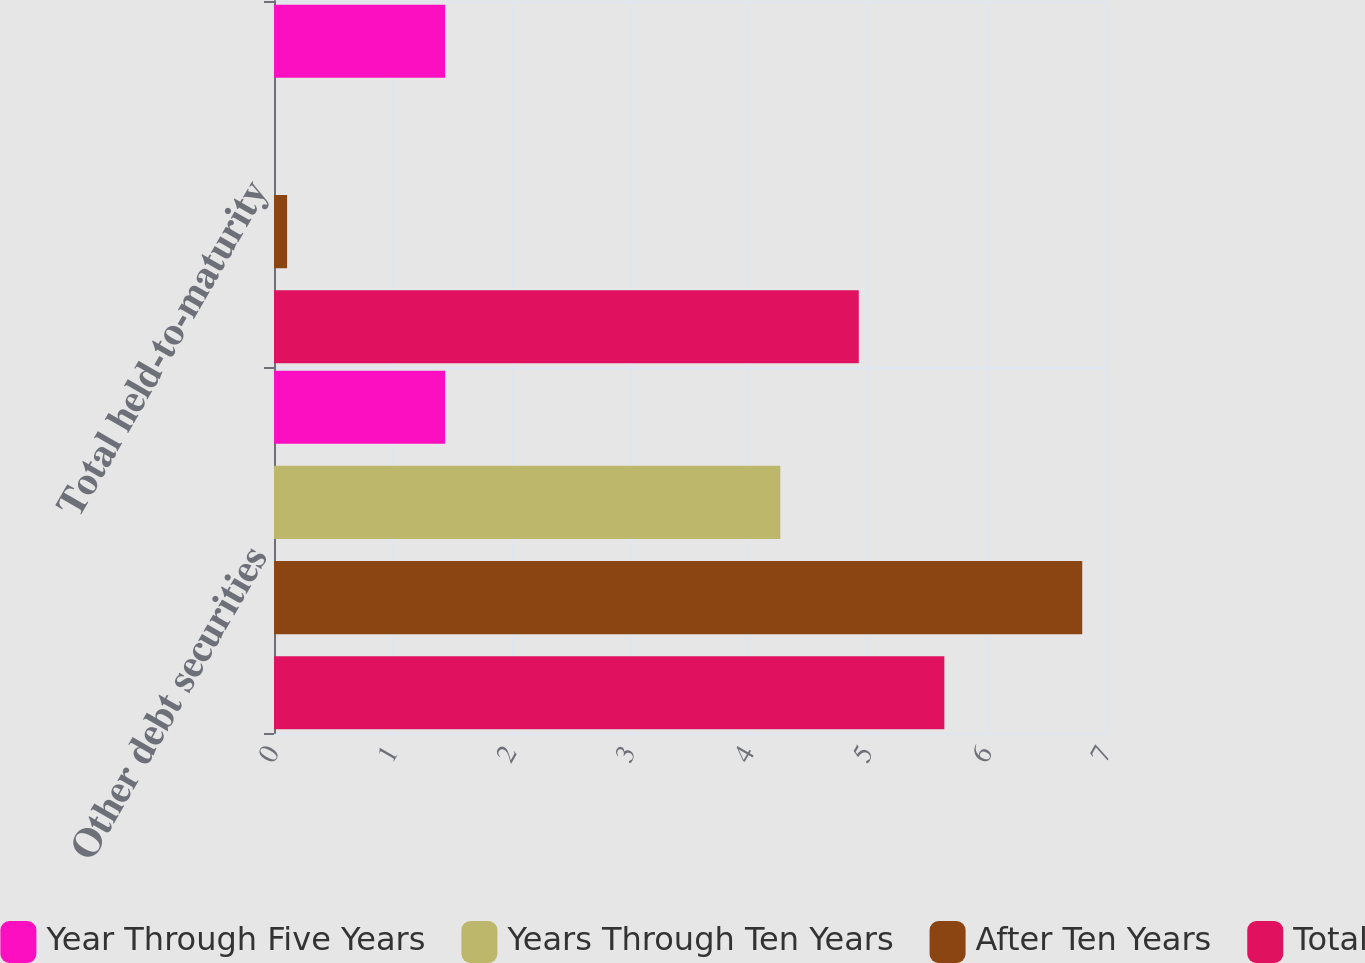Convert chart to OTSL. <chart><loc_0><loc_0><loc_500><loc_500><stacked_bar_chart><ecel><fcel>Other debt securities<fcel>Total held-to-maturity<nl><fcel>Year Through Five Years<fcel>1.44<fcel>1.44<nl><fcel>Years Through Ten Years<fcel>4.26<fcel>0<nl><fcel>After Ten Years<fcel>6.8<fcel>0.11<nl><fcel>Total<fcel>5.64<fcel>4.92<nl></chart> 